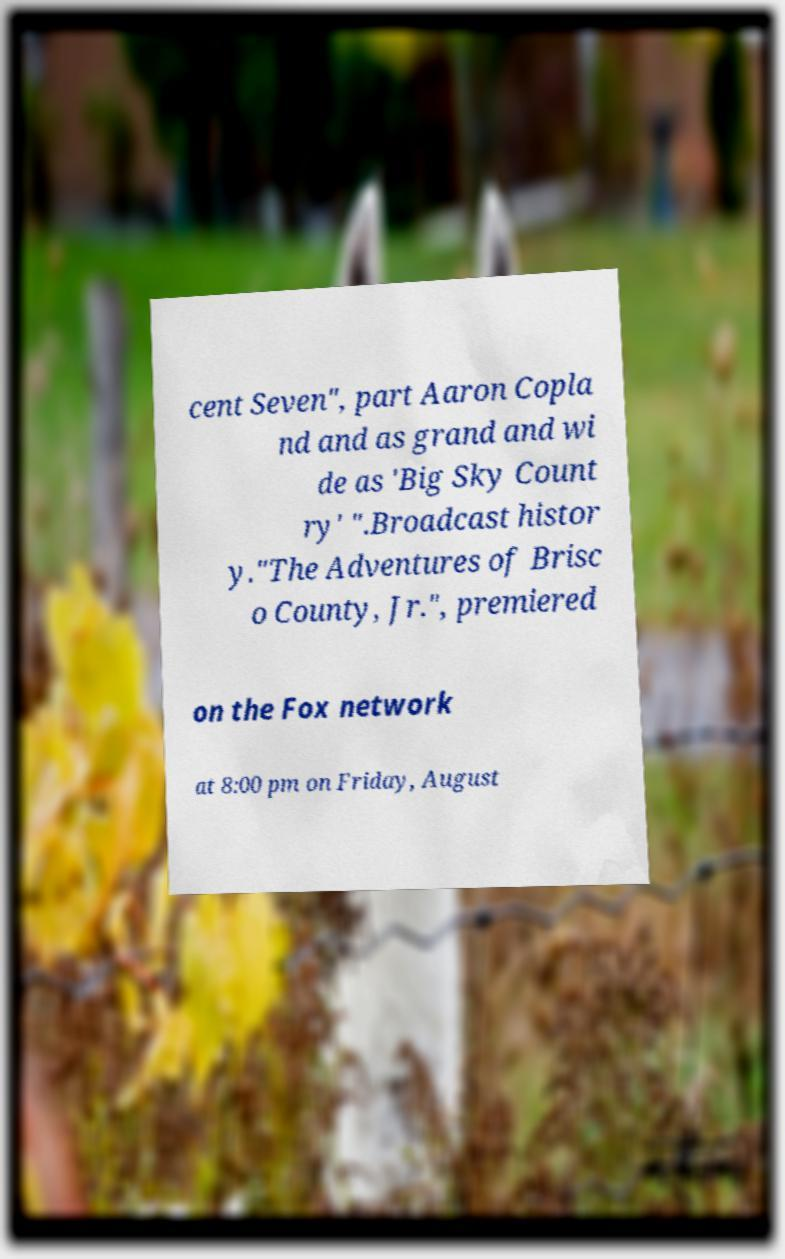Please identify and transcribe the text found in this image. cent Seven", part Aaron Copla nd and as grand and wi de as 'Big Sky Count ry' ".Broadcast histor y."The Adventures of Brisc o County, Jr.", premiered on the Fox network at 8:00 pm on Friday, August 